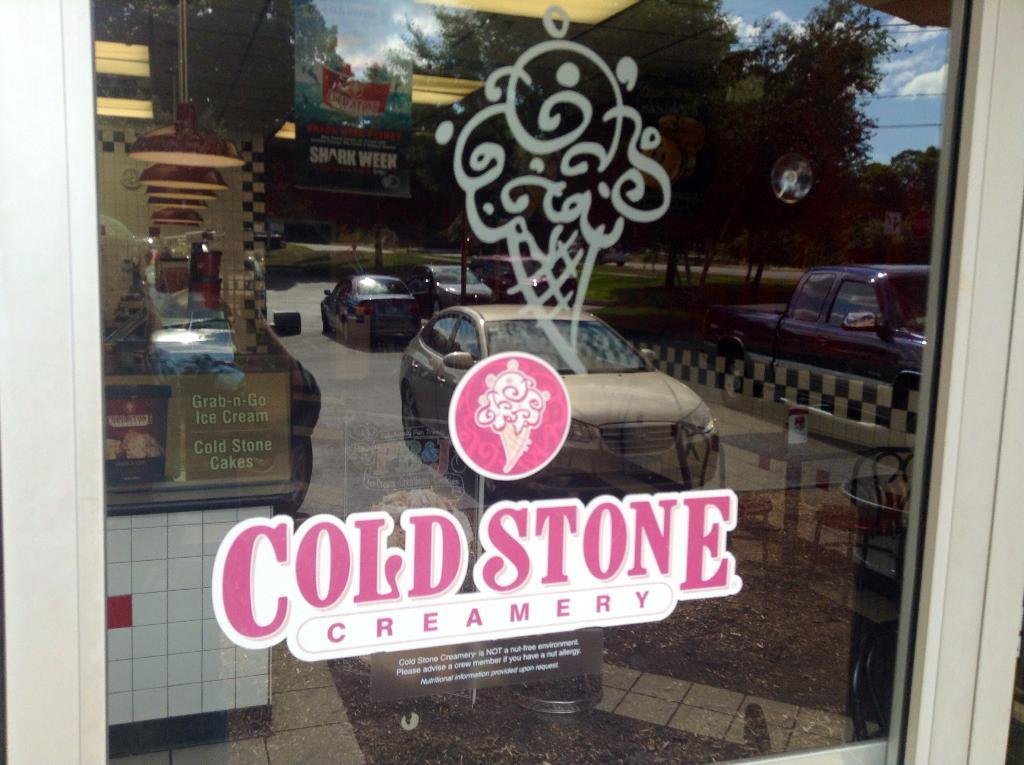What object is present in the image that can be used for holding liquids? There is a glass in the image that can be used for holding liquids. What is written or printed on the glass? There is text on the glass. What is the symbol or design on the glass? There is a logo on the glass. What can be seen reflected in the glass? The glass reflects cars, trees, grass, a hoarding, and the sky. What type of pin can be seen holding the list on the glass? There is no pin or list present in the image; the glass only reflects various objects and elements. 